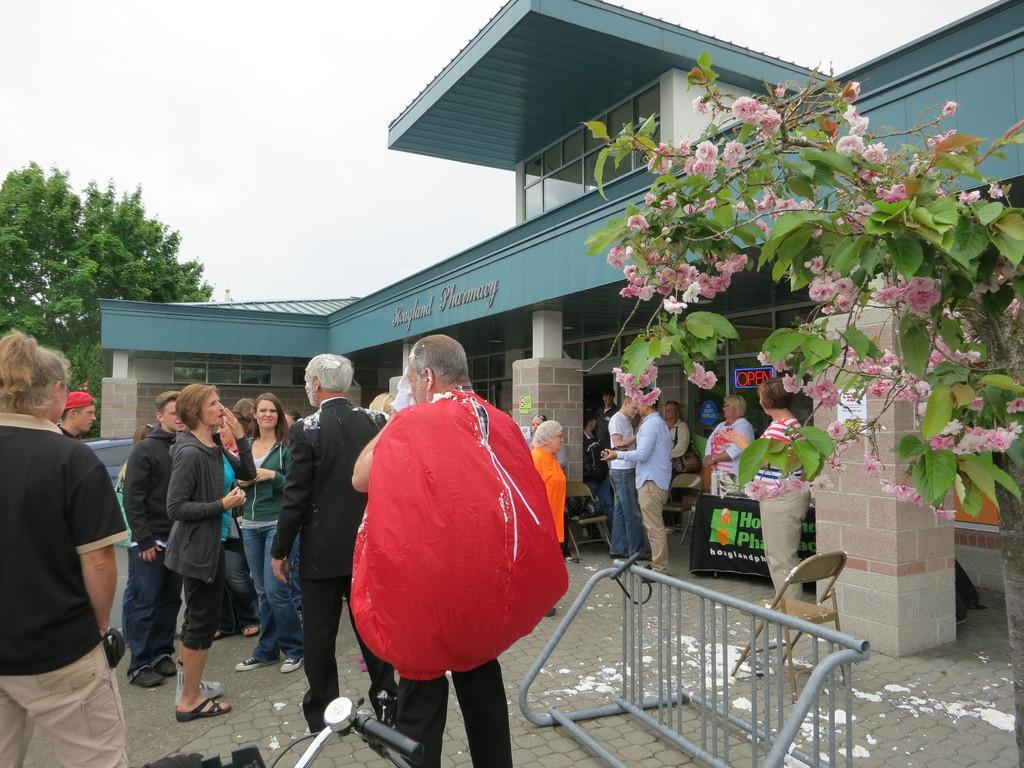Please provide a concise description of this image. In this image I can see in the middle a man is carrying a red color bag. In the middle a group of people are standing, on the right side it looks like a building, there are trees on either side of this image. At the bottom there is an iron grill, beside it, there is a chair. At the top there is the sky. 